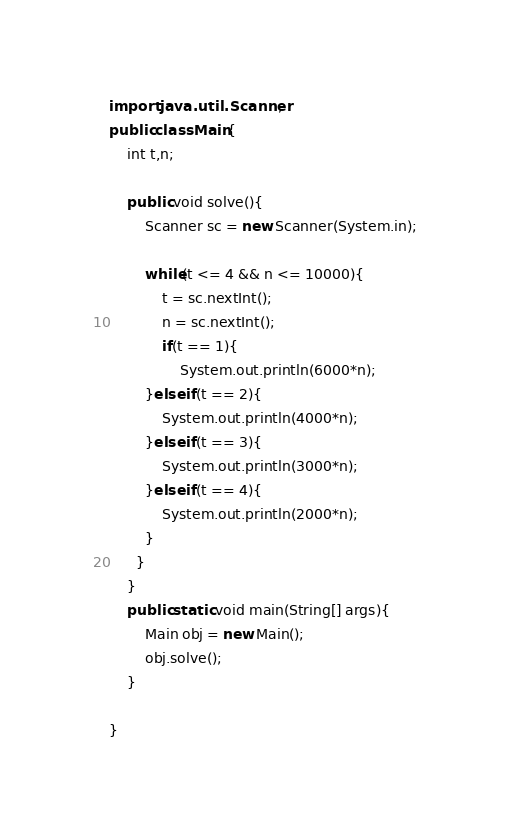<code> <loc_0><loc_0><loc_500><loc_500><_Java_>import java.util.Scanner;
public class Main{
    int t,n;
    
    public void solve(){
        Scanner sc = new Scanner(System.in);
		
        while(t <= 4 && n <= 10000){
            t = sc.nextInt();
            n = sc.nextInt();
		    if(t == 1){
				System.out.println(6000*n);
        }else if(t == 2){
			System.out.println(4000*n);
        }else if(t == 3){
			System.out.println(3000*n);
        }else if(t == 4){
			System.out.println(2000*n);
        }
      }
    }
    public static void main(String[] args){
        Main obj = new Main();
        obj.solve();
    }
    
}</code> 